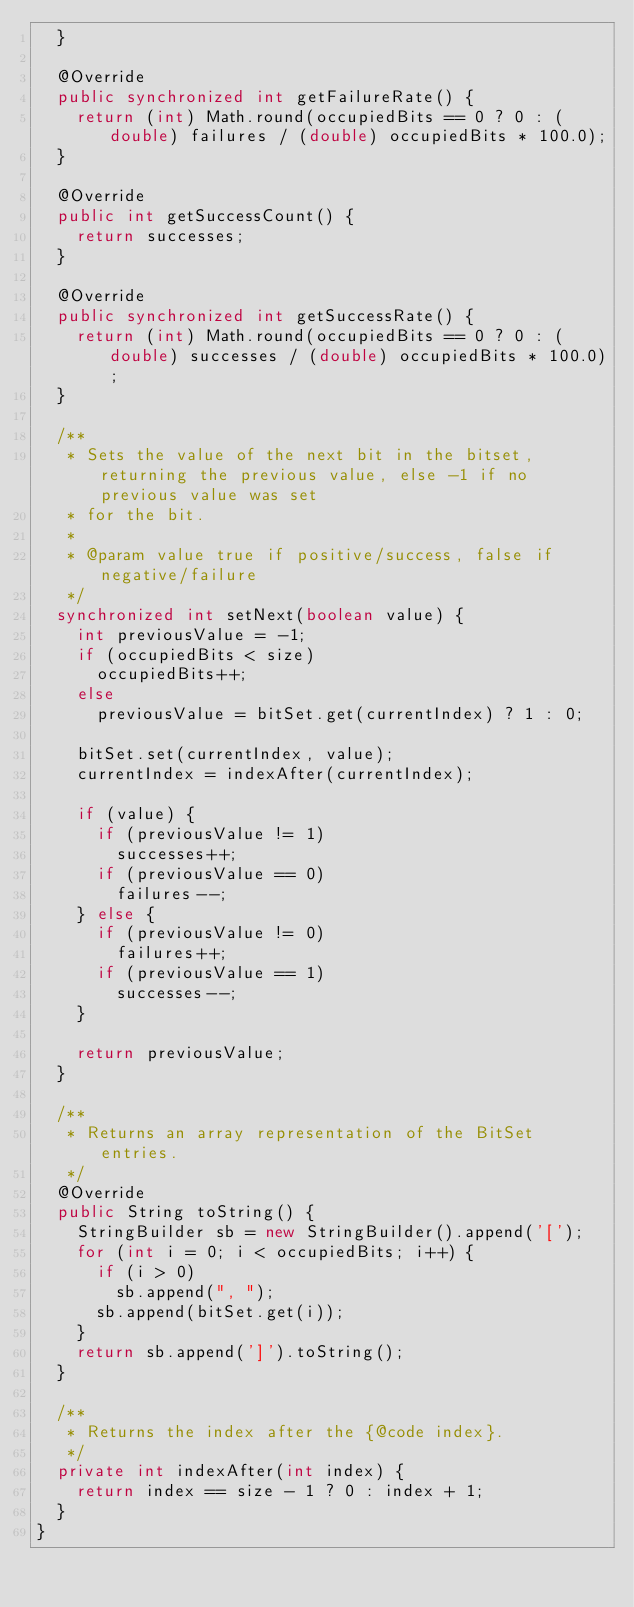Convert code to text. <code><loc_0><loc_0><loc_500><loc_500><_Java_>  }

  @Override
  public synchronized int getFailureRate() {
    return (int) Math.round(occupiedBits == 0 ? 0 : (double) failures / (double) occupiedBits * 100.0);
  }

  @Override
  public int getSuccessCount() {
    return successes;
  }

  @Override
  public synchronized int getSuccessRate() {
    return (int) Math.round(occupiedBits == 0 ? 0 : (double) successes / (double) occupiedBits * 100.0);
  }

  /**
   * Sets the value of the next bit in the bitset, returning the previous value, else -1 if no previous value was set
   * for the bit.
   *
   * @param value true if positive/success, false if negative/failure
   */
  synchronized int setNext(boolean value) {
    int previousValue = -1;
    if (occupiedBits < size)
      occupiedBits++;
    else
      previousValue = bitSet.get(currentIndex) ? 1 : 0;

    bitSet.set(currentIndex, value);
    currentIndex = indexAfter(currentIndex);

    if (value) {
      if (previousValue != 1)
        successes++;
      if (previousValue == 0)
        failures--;
    } else {
      if (previousValue != 0)
        failures++;
      if (previousValue == 1)
        successes--;
    }

    return previousValue;
  }

  /**
   * Returns an array representation of the BitSet entries.
   */
  @Override
  public String toString() {
    StringBuilder sb = new StringBuilder().append('[');
    for (int i = 0; i < occupiedBits; i++) {
      if (i > 0)
        sb.append(", ");
      sb.append(bitSet.get(i));
    }
    return sb.append(']').toString();
  }

  /**
   * Returns the index after the {@code index}.
   */
  private int indexAfter(int index) {
    return index == size - 1 ? 0 : index + 1;
  }
}</code> 